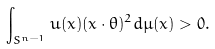Convert formula to latex. <formula><loc_0><loc_0><loc_500><loc_500>\int _ { S ^ { n - 1 } } u ( x ) ( x \cdot \theta ) ^ { 2 } d \mu ( x ) > 0 .</formula> 